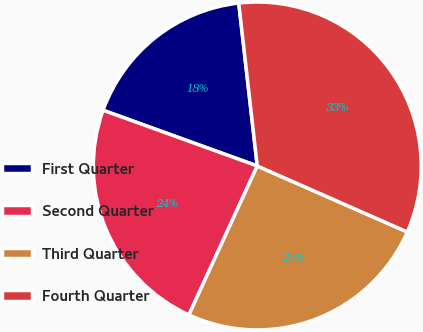<chart> <loc_0><loc_0><loc_500><loc_500><pie_chart><fcel>First Quarter<fcel>Second Quarter<fcel>Third Quarter<fcel>Fourth Quarter<nl><fcel>17.68%<fcel>23.67%<fcel>25.25%<fcel>33.4%<nl></chart> 